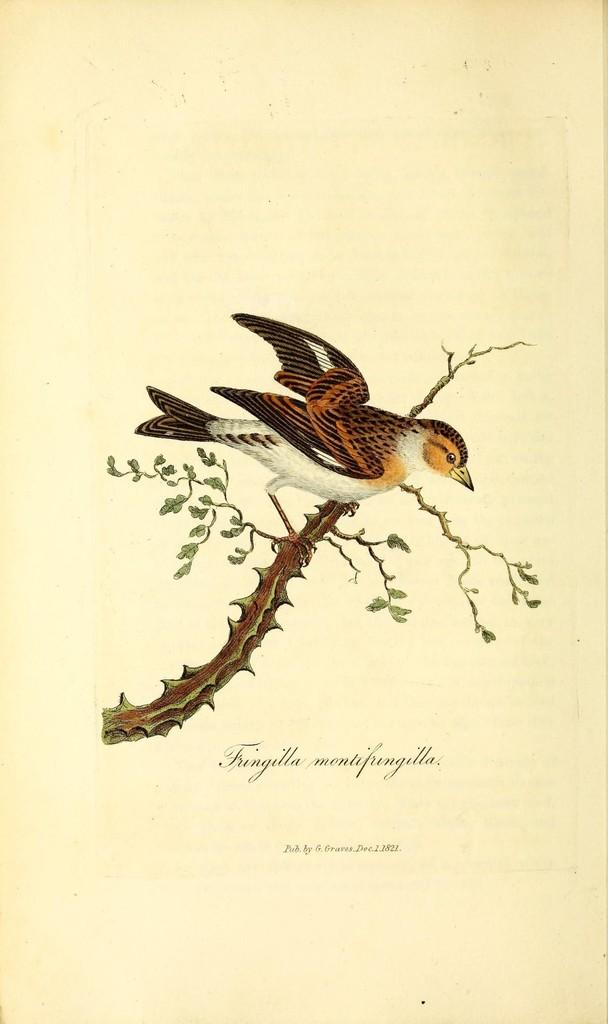What is depicted on the paper in the image? There is a picture of a bird and a picture of a tree on the paper. What else can be found on the paper besides the images? There is text on the paper. What type of flower is growing in the basin in the image? There is no flower or basin present in the image; it only features a paper with a bird, a tree, and text. 